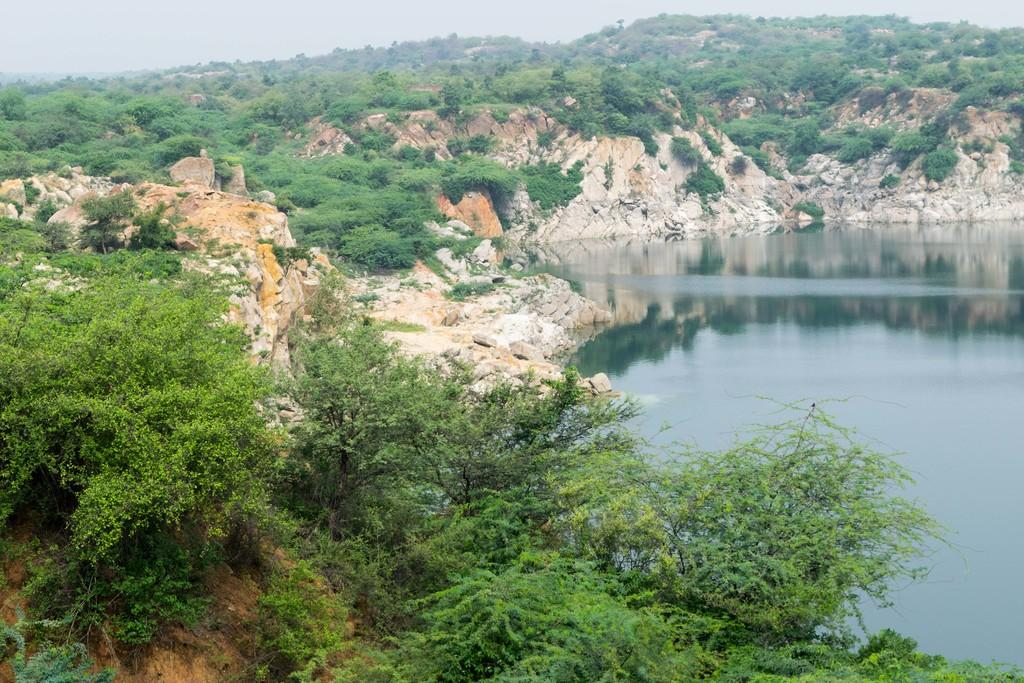What type of natural formations can be seen in the image? There are rocks in the image. What is growing on the rocks? There are trees and plants on the rocks. What else can be seen in the image besides the rocks and vegetation? There is water visible in the image. What is visible in the background of the image? The sky is visible in the background of the image. What type of creature can be seen turning a quarter on the rocks in the image? There is no creature present in the image, and no one is turning a quarter on the rocks. 